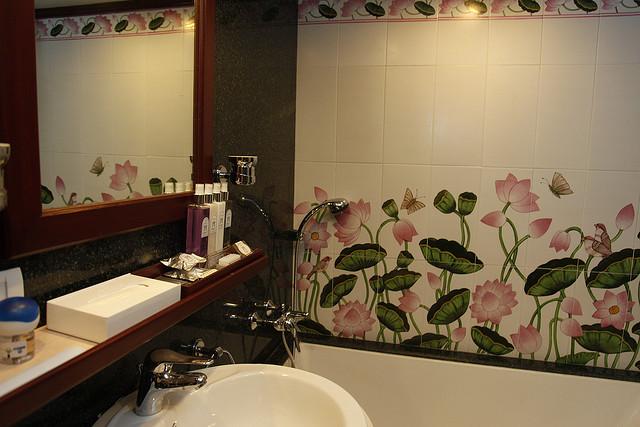Are there flowers on the wall?
Be succinct. Yes. Why is a showerhead on the wall by the flower  picture?
Write a very short answer. Shower. What color is the sink?
Short answer required. White. 